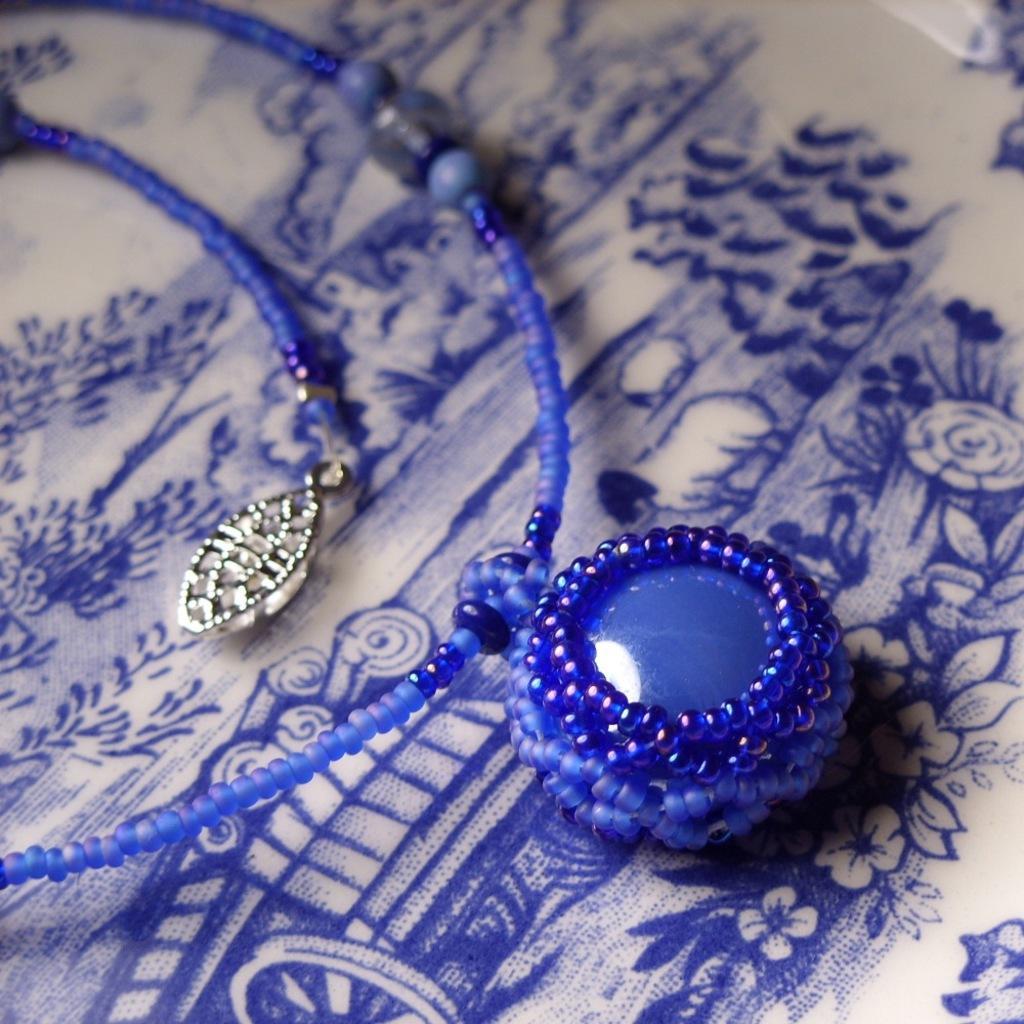Describe this image in one or two sentences. In this image we can see a blue colored jewelry. 